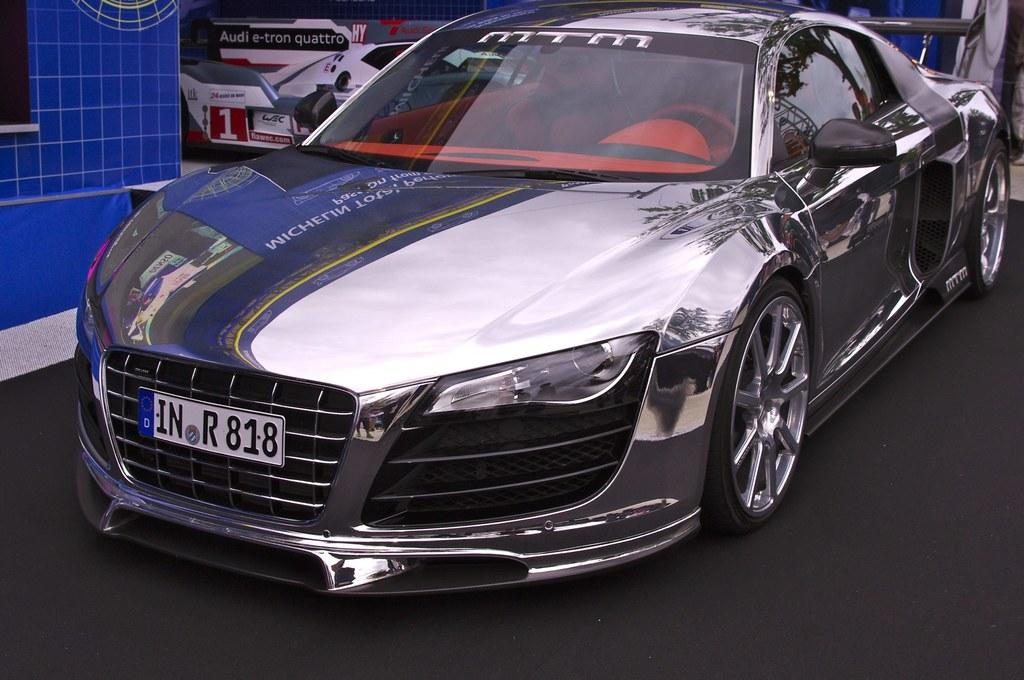What is the main subject of the image? The main subject of the image is a car. Where is the car located in the image? The car is parked on a surface in the image. What type of surface is the car parked on? The surface is a mat. What type of wilderness can be seen in the background of the image? There is no wilderness visible in the image; the image only shows a car parked on a mat. 